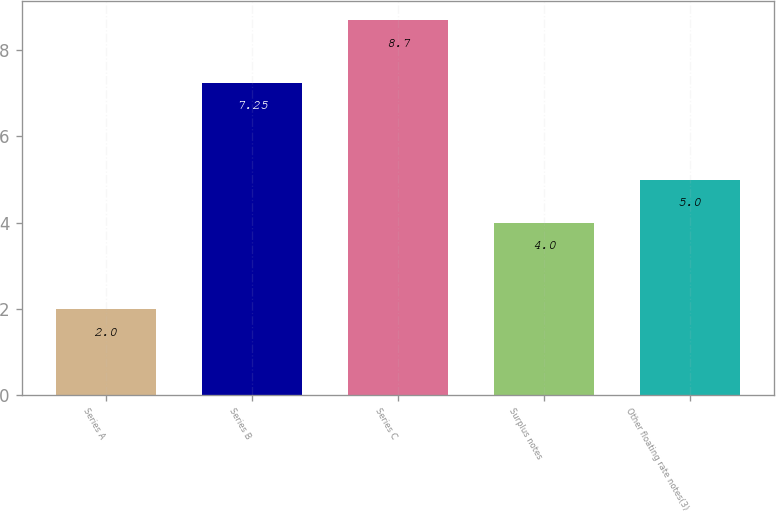<chart> <loc_0><loc_0><loc_500><loc_500><bar_chart><fcel>Series A<fcel>Series B<fcel>Series C<fcel>Surplus notes<fcel>Other floating rate notes(3)<nl><fcel>2<fcel>7.25<fcel>8.7<fcel>4<fcel>5<nl></chart> 